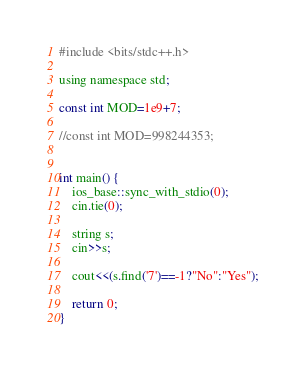<code> <loc_0><loc_0><loc_500><loc_500><_C_>#include <bits/stdc++.h>
 
using namespace std;
 
const int MOD=1e9+7;

//const int MOD=998244353;


int main() {
    ios_base::sync_with_stdio(0);
    cin.tie(0);
	
	string s;
	cin>>s;
	
	cout<<(s.find('7')==-1?"No":"Yes");

    return 0;
}</code> 